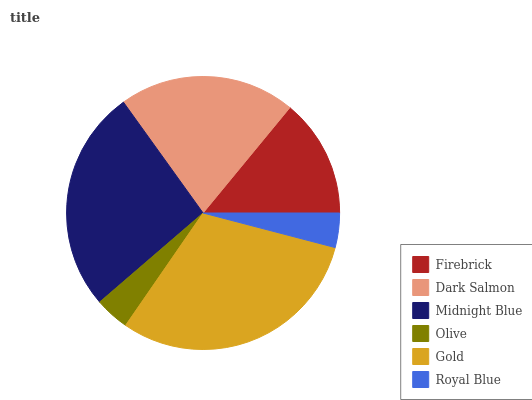Is Royal Blue the minimum?
Answer yes or no. Yes. Is Gold the maximum?
Answer yes or no. Yes. Is Dark Salmon the minimum?
Answer yes or no. No. Is Dark Salmon the maximum?
Answer yes or no. No. Is Dark Salmon greater than Firebrick?
Answer yes or no. Yes. Is Firebrick less than Dark Salmon?
Answer yes or no. Yes. Is Firebrick greater than Dark Salmon?
Answer yes or no. No. Is Dark Salmon less than Firebrick?
Answer yes or no. No. Is Dark Salmon the high median?
Answer yes or no. Yes. Is Firebrick the low median?
Answer yes or no. Yes. Is Gold the high median?
Answer yes or no. No. Is Olive the low median?
Answer yes or no. No. 